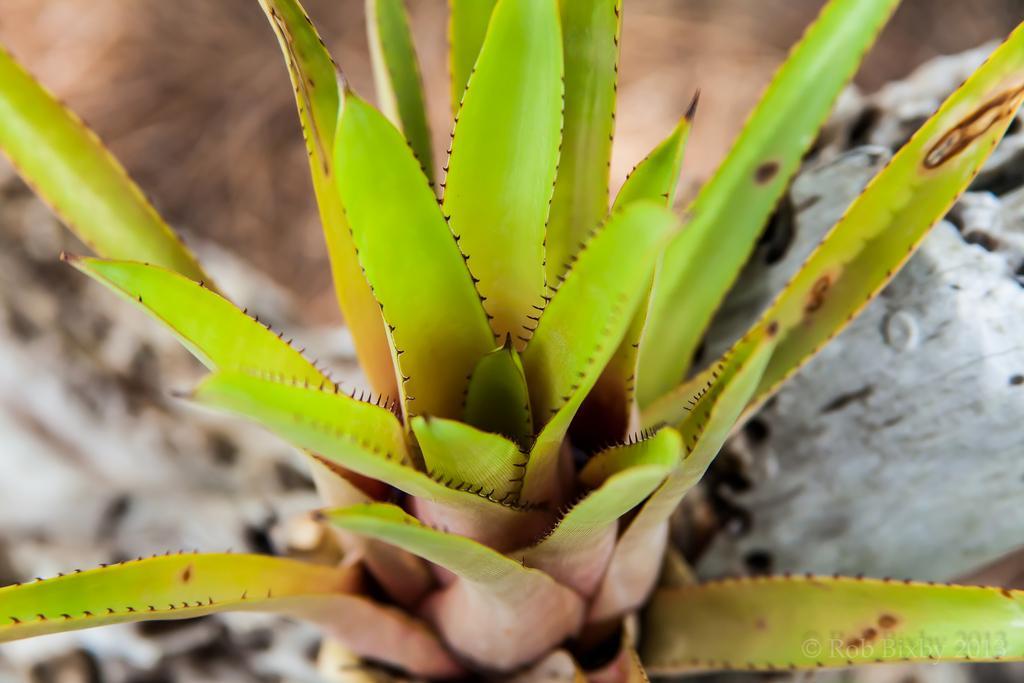Could you give a brief overview of what you see in this image? In this image we can see an aloe Vera plant and the background is blurred. 